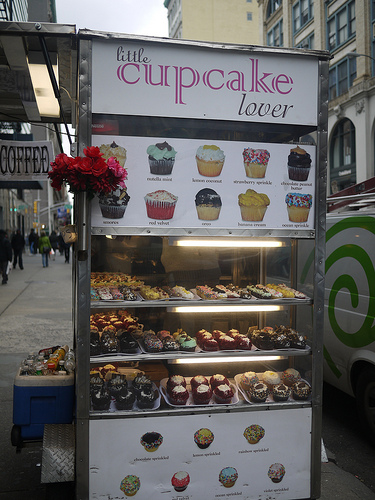<image>
Is there a sprinkles next to the sprinkles? Yes. The sprinkles is positioned adjacent to the sprinkles, located nearby in the same general area. Is there a cupcake above the sidewalk? Yes. The cupcake is positioned above the sidewalk in the vertical space, higher up in the scene. Where is the cupcake in relation to the lightbulb? Is it above the lightbulb? Yes. The cupcake is positioned above the lightbulb in the vertical space, higher up in the scene. Is there a green jacket on the person? No. The green jacket is not positioned on the person. They may be near each other, but the green jacket is not supported by or resting on top of the person. 